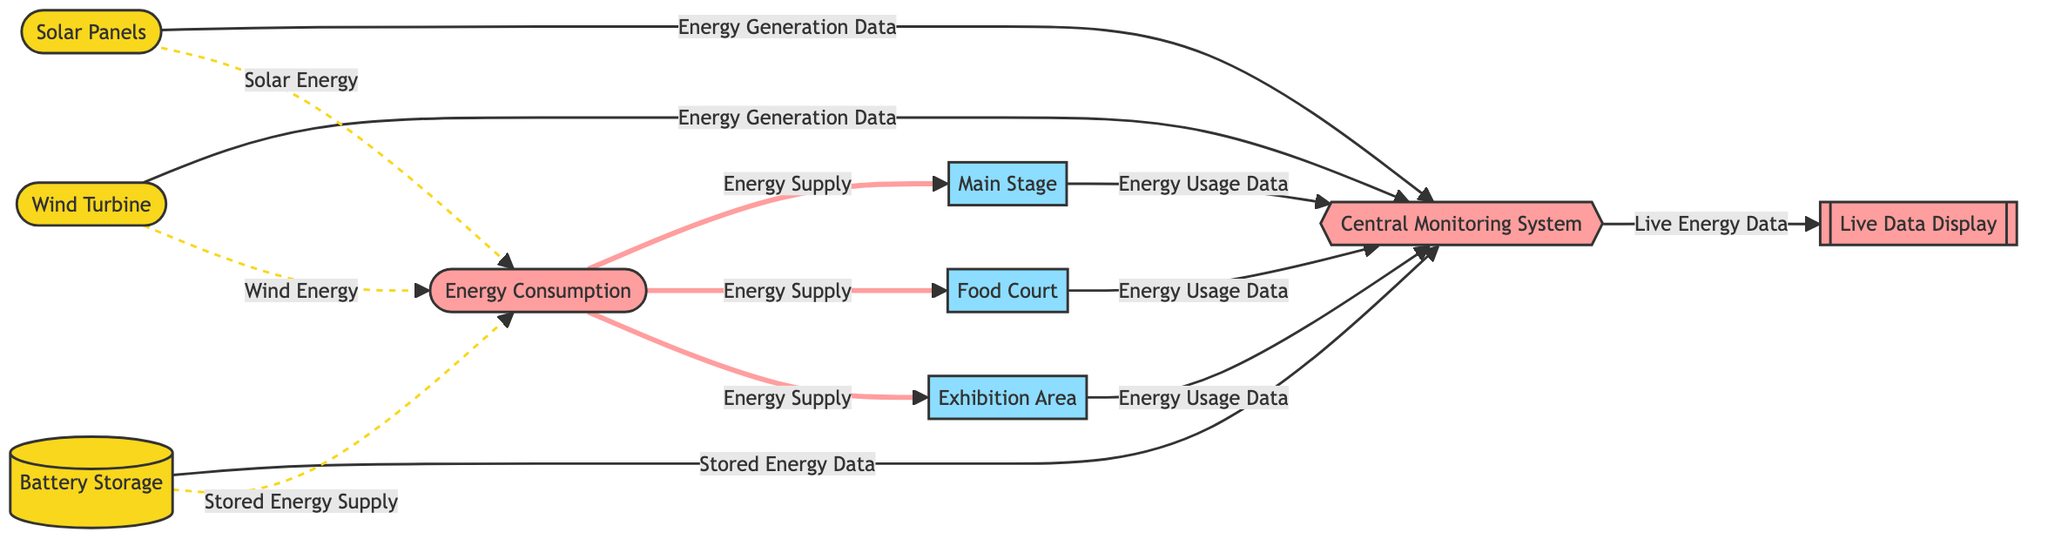What are the sources of energy generation displayed in the diagram? The diagram shows three sources of energy generation: solar panels, wind turbine, and battery storage. Each of these energy sources is represented by a distinct node.
Answer: solar panels, wind turbine, battery storage How many areas in the event venue are monitored for energy usage? There are three areas in the event venue monitored for energy usage: main stage, food court, and exhibition area. Each area is a node connected to the central monitoring system.
Answer: 3 Which node receives energy usage data from the food court? The food court sends energy usage data to the central monitoring system. This connection is clearly illustrated in the diagram through the arrow pointing from the food court to the central monitor.
Answer: central monitoring system What type of information does the central monitoring system provide to the live data display? The central monitoring system provides live energy data to the live data display, as indicated by the arrow leading from the central monitor to the live data display.
Answer: live energy data What energy sources are connected to the energy consumption node? The energy consumption node receives contributions from solar energy, wind energy, and stored energy supply as illustrated by the dashed lines leading to the node.
Answer: solar energy, wind energy, stored energy supply If energy supply from energy consumption is needed for the main stage, where is it sourced from? Energy supply for the main stage is sourced from the energy consumption node, which aggregates the energy provided by the three energy sources previously mentioned in the diagram.
Answer: energy consumption How many distinct energy pathways are represented in the diagram? The diagram represents a total of six distinct pathways: three from energy sources to the central monitoring system, three from the event venue areas to the central monitoring system, and three from the central monitoring system to the live data display. Therefore, careful counting shows that there are six distinctive connections.
Answer: 6 What color represents the energy sources in the diagram? The energy sources in the diagram are represented with the color yellow, as indicated by the classname assigned to the energy source nodes.
Answer: yellow What is the function of the live data display in the diagram? The live data display serves as a visual output that presents live energy data that is filtered and aggregated from the central monitoring system. This functionality is illustrated by the directed arrow leading from the central monitor to the live data display.
Answer: visual output of live energy data 